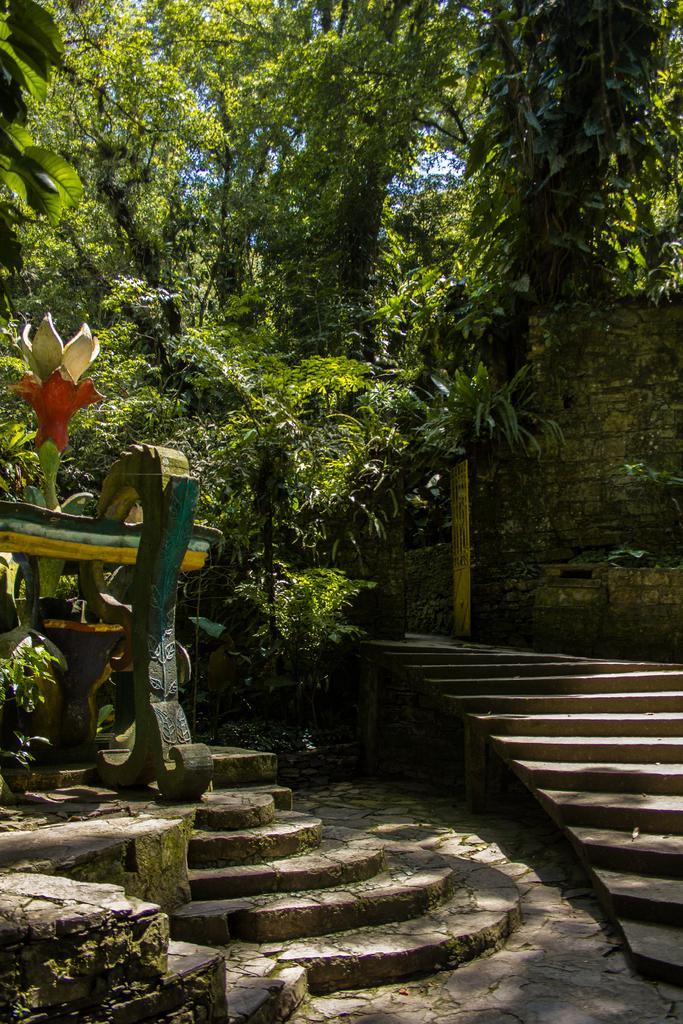Describe this image in one or two sentences. In this picture I can see the steps in front and in the background I can see the trees and the wall. 